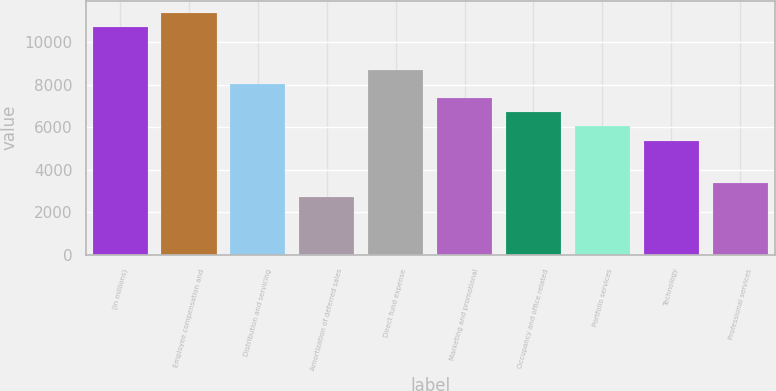<chart> <loc_0><loc_0><loc_500><loc_500><bar_chart><fcel>(in millions)<fcel>Employee compensation and<fcel>Distribution and servicing<fcel>Amortization of deferred sales<fcel>Direct fund expense<fcel>Marketing and promotional<fcel>Occupancy and office related<fcel>Portfolio services<fcel>Technology<fcel>Professional services<nl><fcel>10715.2<fcel>11383.4<fcel>8042.4<fcel>2696.8<fcel>8710.6<fcel>7374.2<fcel>6706<fcel>6037.8<fcel>5369.6<fcel>3365<nl></chart> 